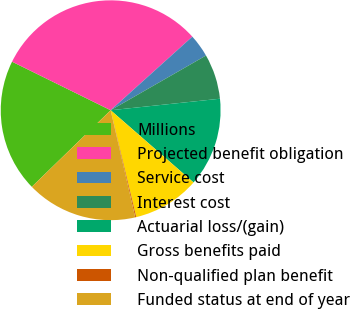<chart> <loc_0><loc_0><loc_500><loc_500><pie_chart><fcel>Millions<fcel>Projected benefit obligation<fcel>Service cost<fcel>Interest cost<fcel>Actuarial loss/(gain)<fcel>Gross benefits paid<fcel>Non-qualified plan benefit<fcel>Funded status at end of year<nl><fcel>19.55%<fcel>31.04%<fcel>3.38%<fcel>6.62%<fcel>13.08%<fcel>9.85%<fcel>0.15%<fcel>16.32%<nl></chart> 